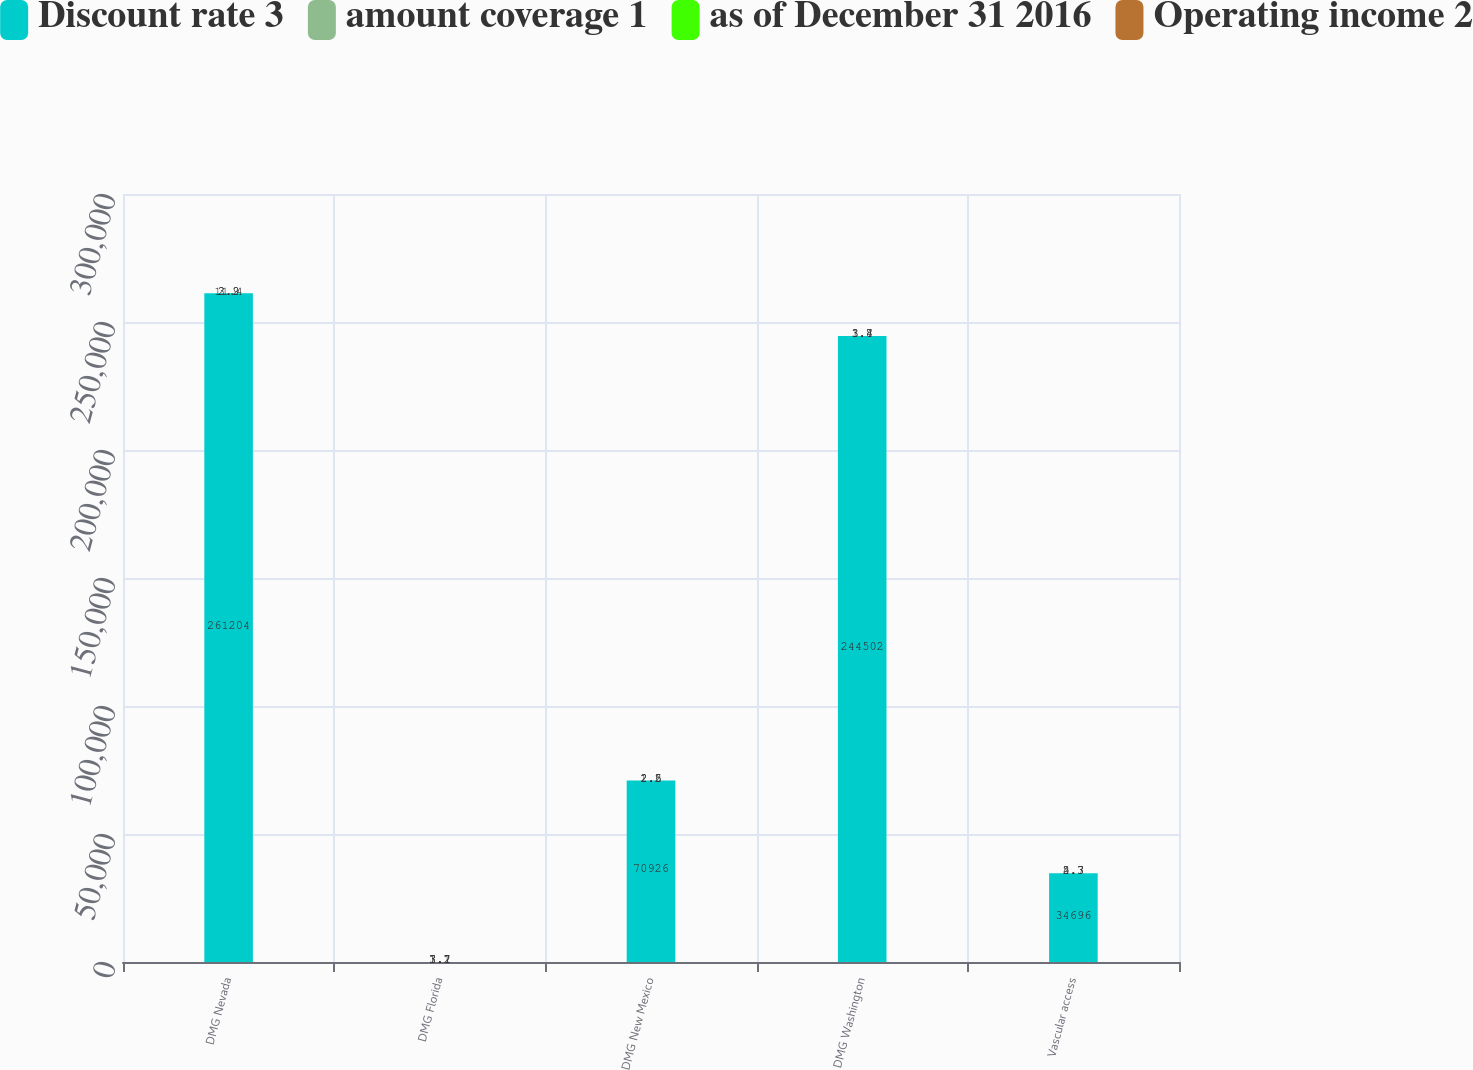Convert chart. <chart><loc_0><loc_0><loc_500><loc_500><stacked_bar_chart><ecel><fcel>DMG Nevada<fcel>DMG Florida<fcel>DMG New Mexico<fcel>DMG Washington<fcel>Vascular access<nl><fcel>Discount rate 3<fcel>261204<fcel>3.7<fcel>70926<fcel>244502<fcel>34696<nl><fcel>amount coverage 1<fcel>11.4<fcel>7.1<fcel>2.6<fcel>3.7<fcel>4.3<nl><fcel>as of December 31 2016<fcel>2.2<fcel>1.7<fcel>1.5<fcel>1.8<fcel>2.7<nl><fcel>Operating income 2<fcel>3.9<fcel>3.2<fcel>2.2<fcel>3.4<fcel>5.3<nl></chart> 